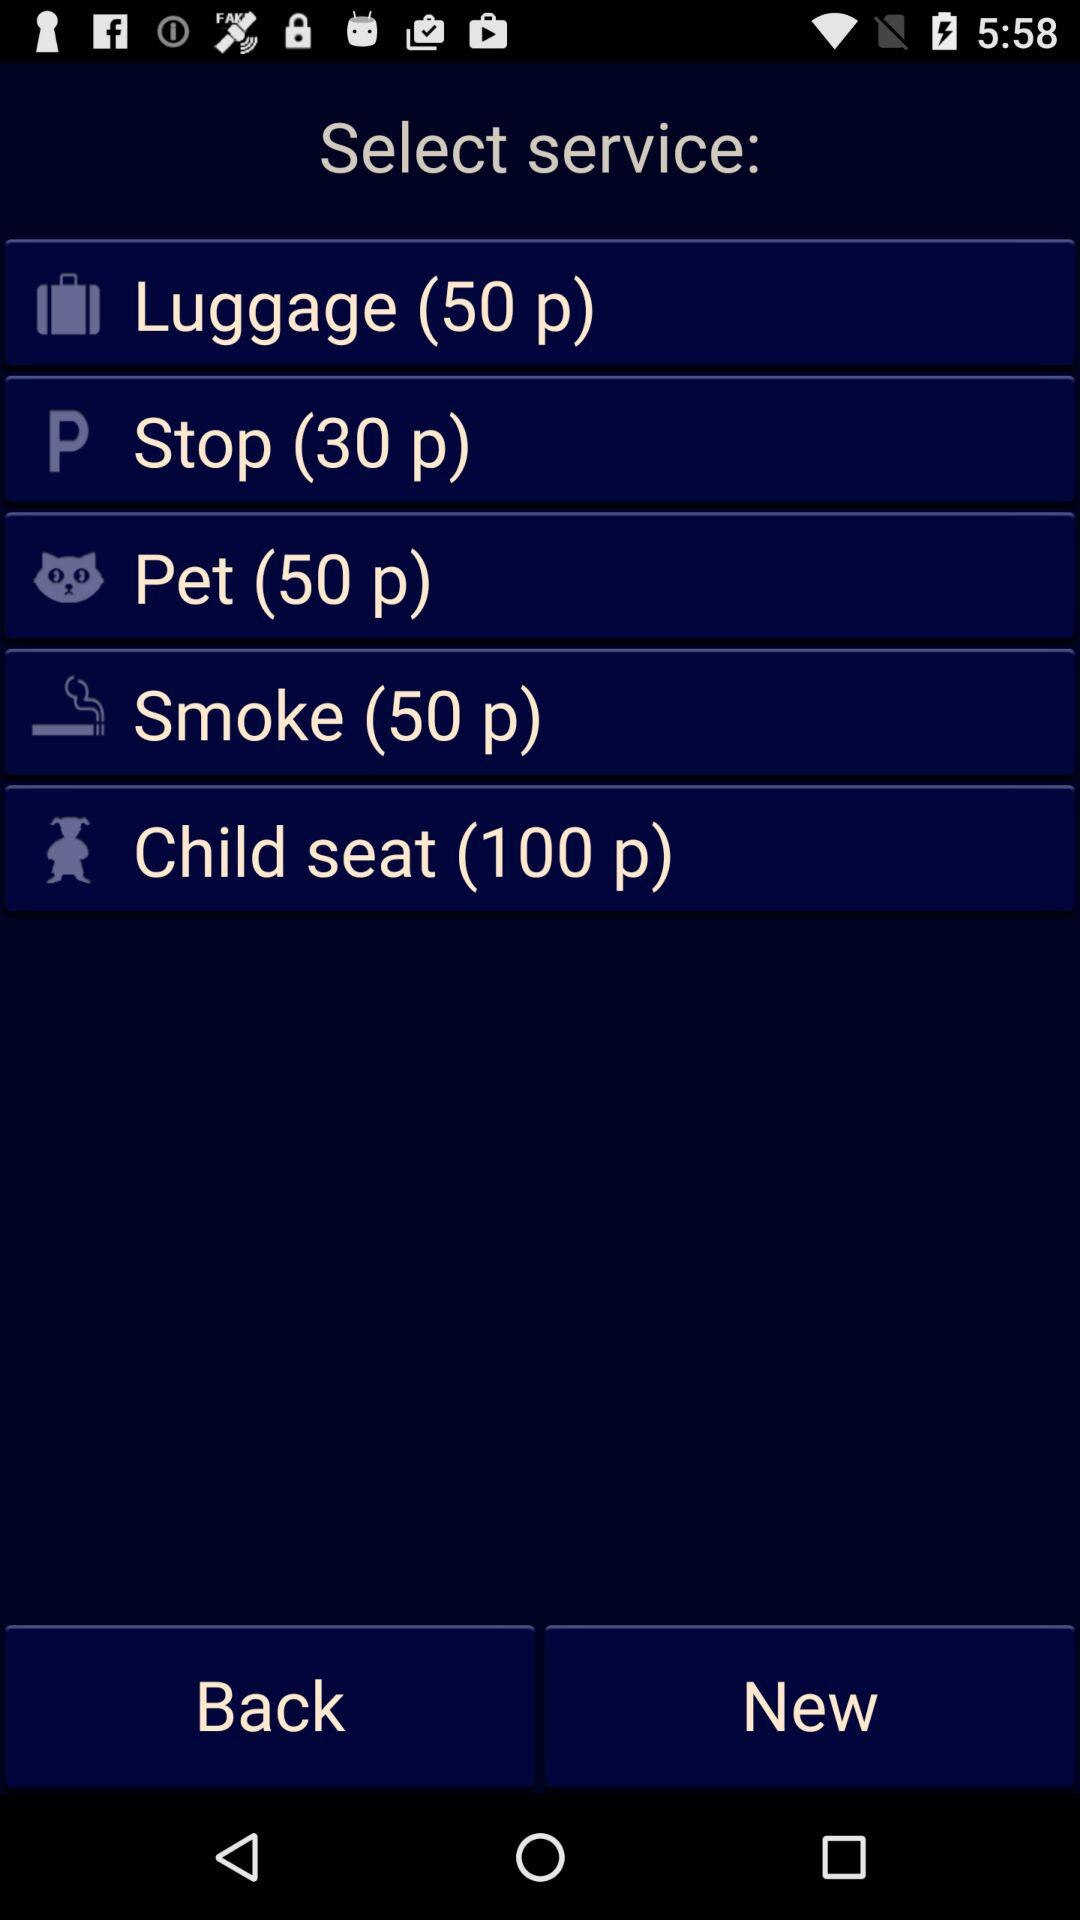How many points is the highest priced service?
Answer the question using a single word or phrase. 100 